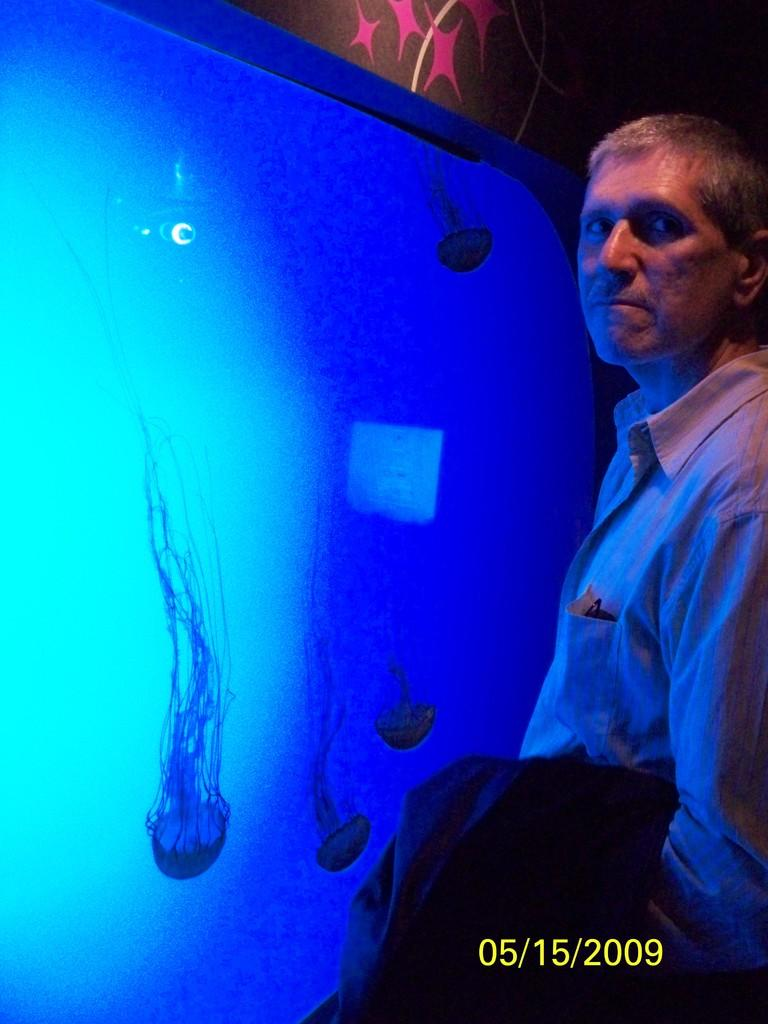What is the person in the image standing in front of? The person is standing in front of an aquarium. What can be seen behind the person? There is a wall behind the person. Can you describe any other details about the image? There is a water mark at the bottom of the image. What type of jail can be seen in the image? There is no jail present in the image; it features a person standing in front of an aquarium. What type of army is depicted in the image? There is no army present in the image. 